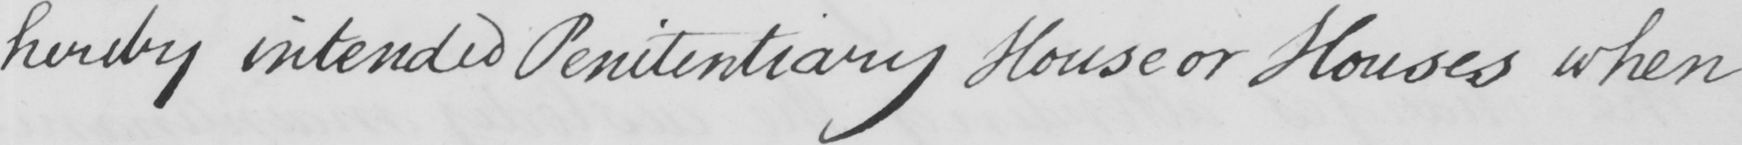Can you read and transcribe this handwriting? hereby intended Penitentiary House or Houses when 